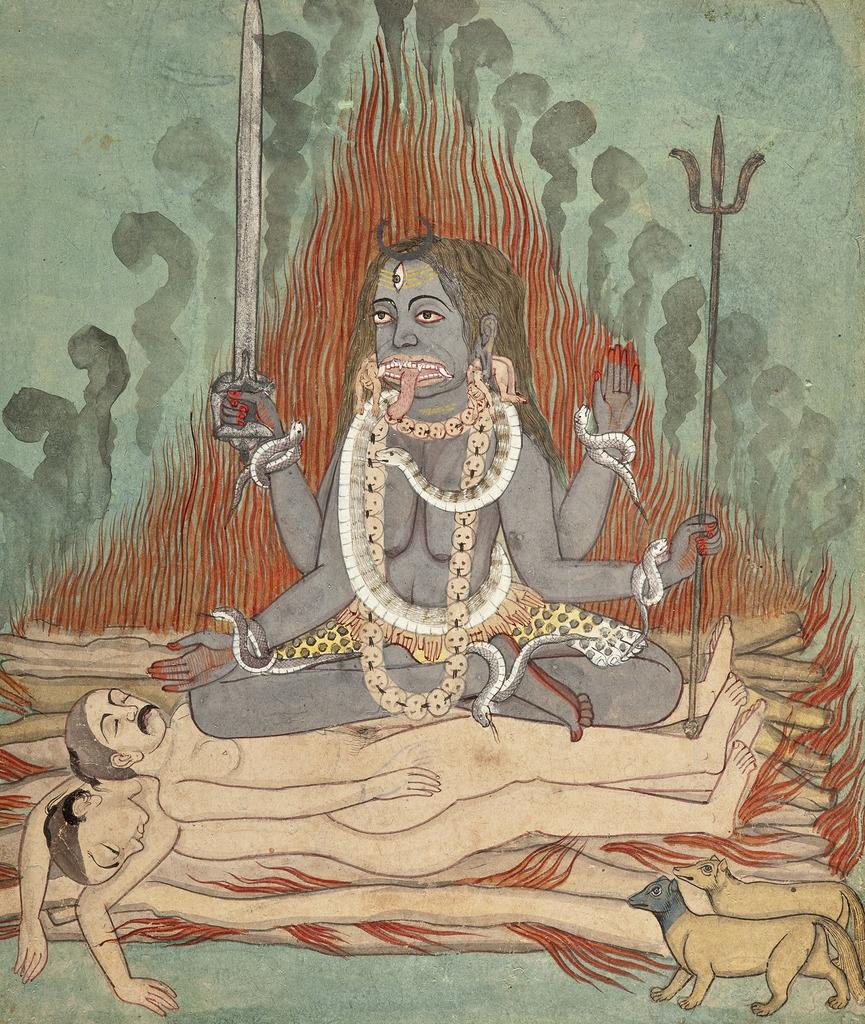What is depicted in the image? There is a drawing of Lord Shiva in the image. What is happening in the drawing? There are two dead bodies in the drawing. What else can be seen on the right side of the drawing? There are two animals on the right side of the drawing. What is the fear level of the animals in the drawing? There is no indication of fear in the drawing, as it only depicts Lord Shiva, two dead bodies, and two animals. --- Facts: 1. There is a person sitting on a chair in the image. 2. The person is holding a book. 3. There is a table next to the chair. 4. There is a lamp on the table. Absurd Topics: ocean, dance, parrot Conversation: What is the person in the image doing? The person is sitting on a chair in the image. What is the person holding in the image? The person is holding a book. What is located next to the chair? There is a table next to the chair. What is on the table? There is a lamp on the table. Reasoning: Let's think step by step in order to produce the conversation. We start by identifying the main subject of the image, which is the person sitting on a chair. Then, we describe the key elements of the scene, including the book the person is holding, the table next to the chair, and the lamp on the table. Each question is designed to elicit a specific detail about the image that is known from the provided facts. Absurd Question/Answer: Can you see the parrot dancing in the ocean in the image? There is no parrot or ocean present in the image; it only features a person sitting on a chair, holding a book, and a table with a lamp. 